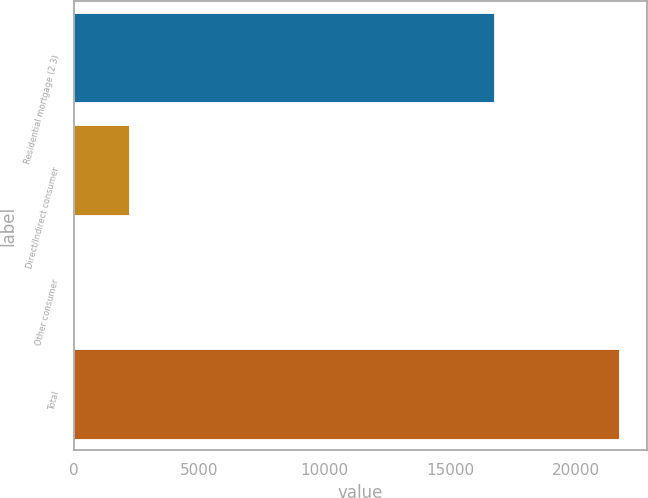Convert chart. <chart><loc_0><loc_0><loc_500><loc_500><bar_chart><fcel>Residential mortgage (2 3)<fcel>Direct/Indirect consumer<fcel>Other consumer<fcel>Total<nl><fcel>16768<fcel>2176.5<fcel>2<fcel>21747<nl></chart> 